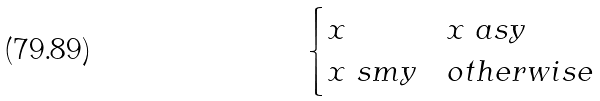Convert formula to latex. <formula><loc_0><loc_0><loc_500><loc_500>\begin{cases} x & x \ a s y \\ x \ s m y & o t h e r w i s e \end{cases}</formula> 